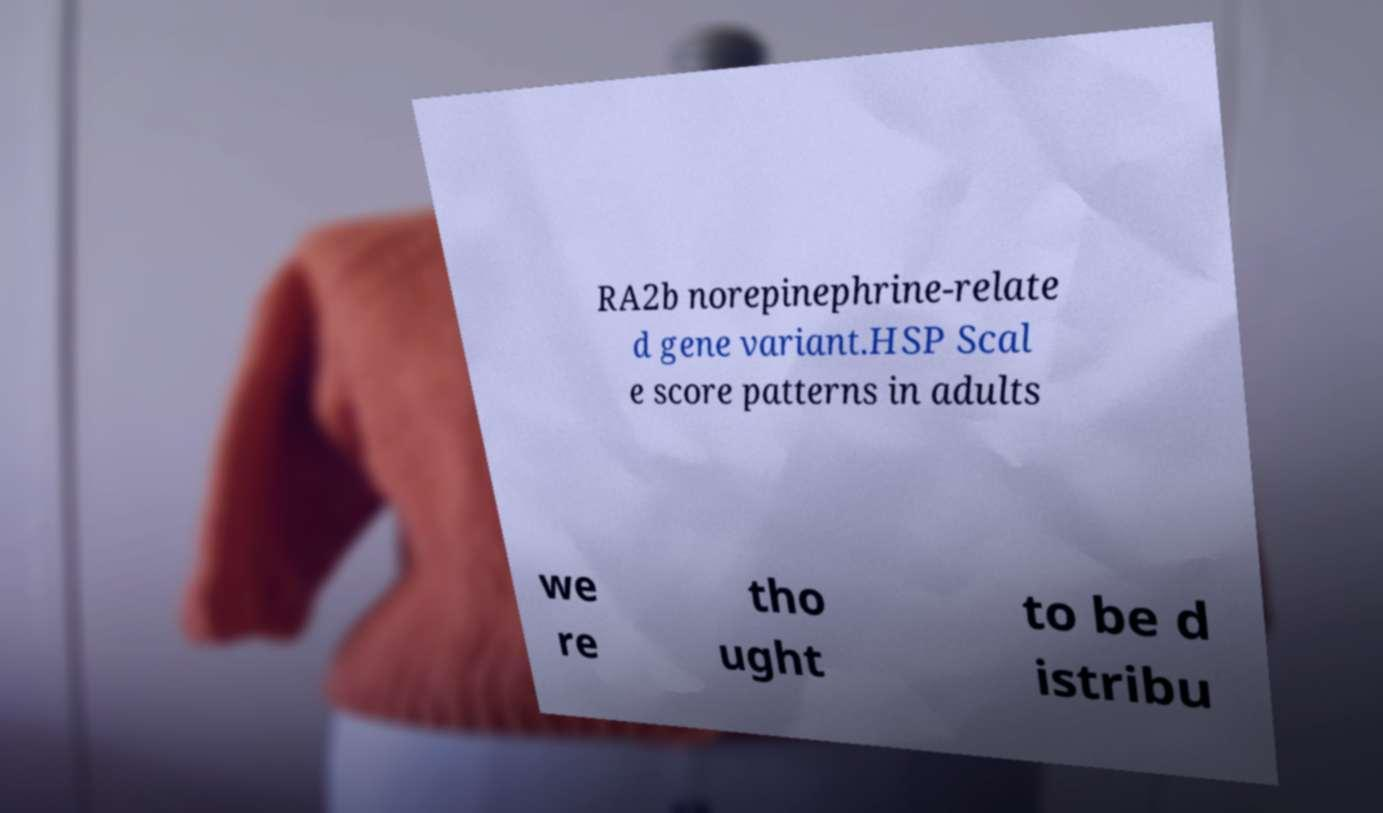Please read and relay the text visible in this image. What does it say? RA2b norepinephrine-relate d gene variant.HSP Scal e score patterns in adults we re tho ught to be d istribu 